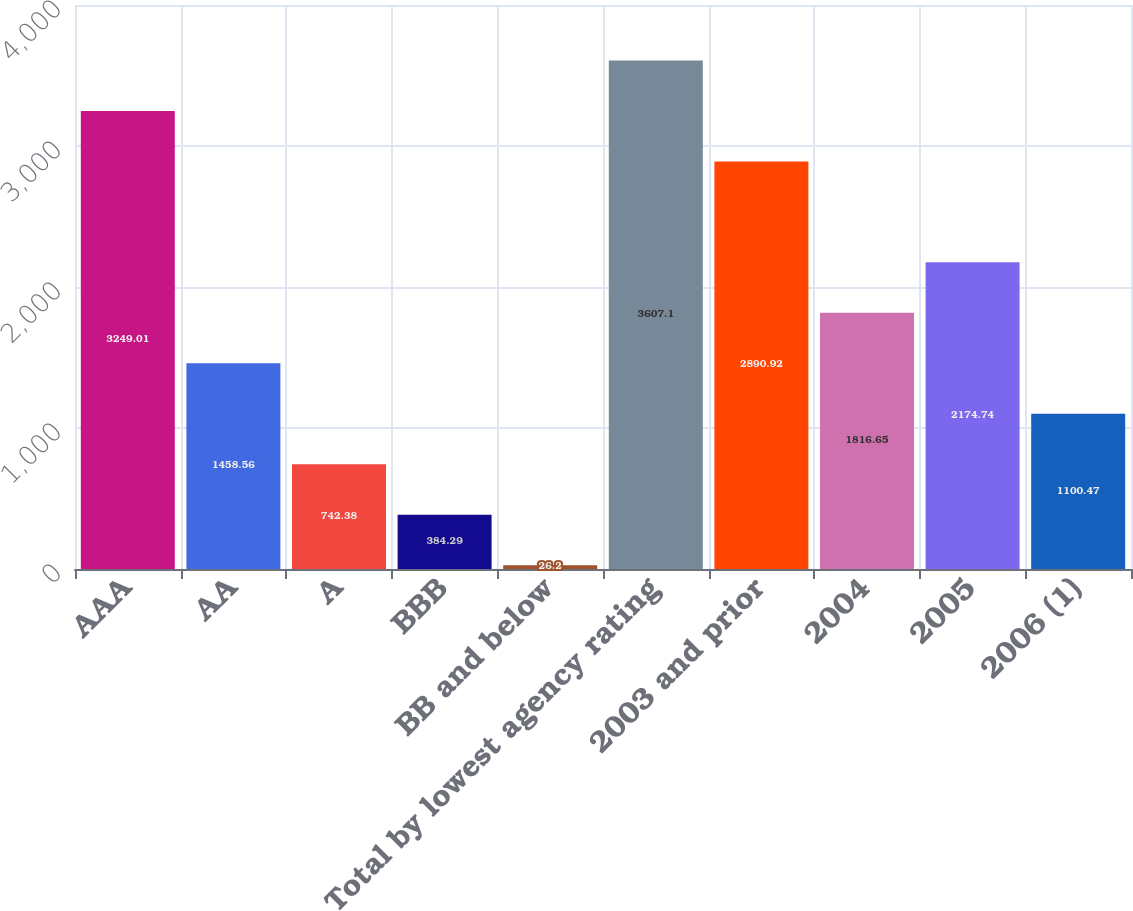<chart> <loc_0><loc_0><loc_500><loc_500><bar_chart><fcel>AAA<fcel>AA<fcel>A<fcel>BBB<fcel>BB and below<fcel>Total by lowest agency rating<fcel>2003 and prior<fcel>2004<fcel>2005<fcel>2006 (1)<nl><fcel>3249.01<fcel>1458.56<fcel>742.38<fcel>384.29<fcel>26.2<fcel>3607.1<fcel>2890.92<fcel>1816.65<fcel>2174.74<fcel>1100.47<nl></chart> 